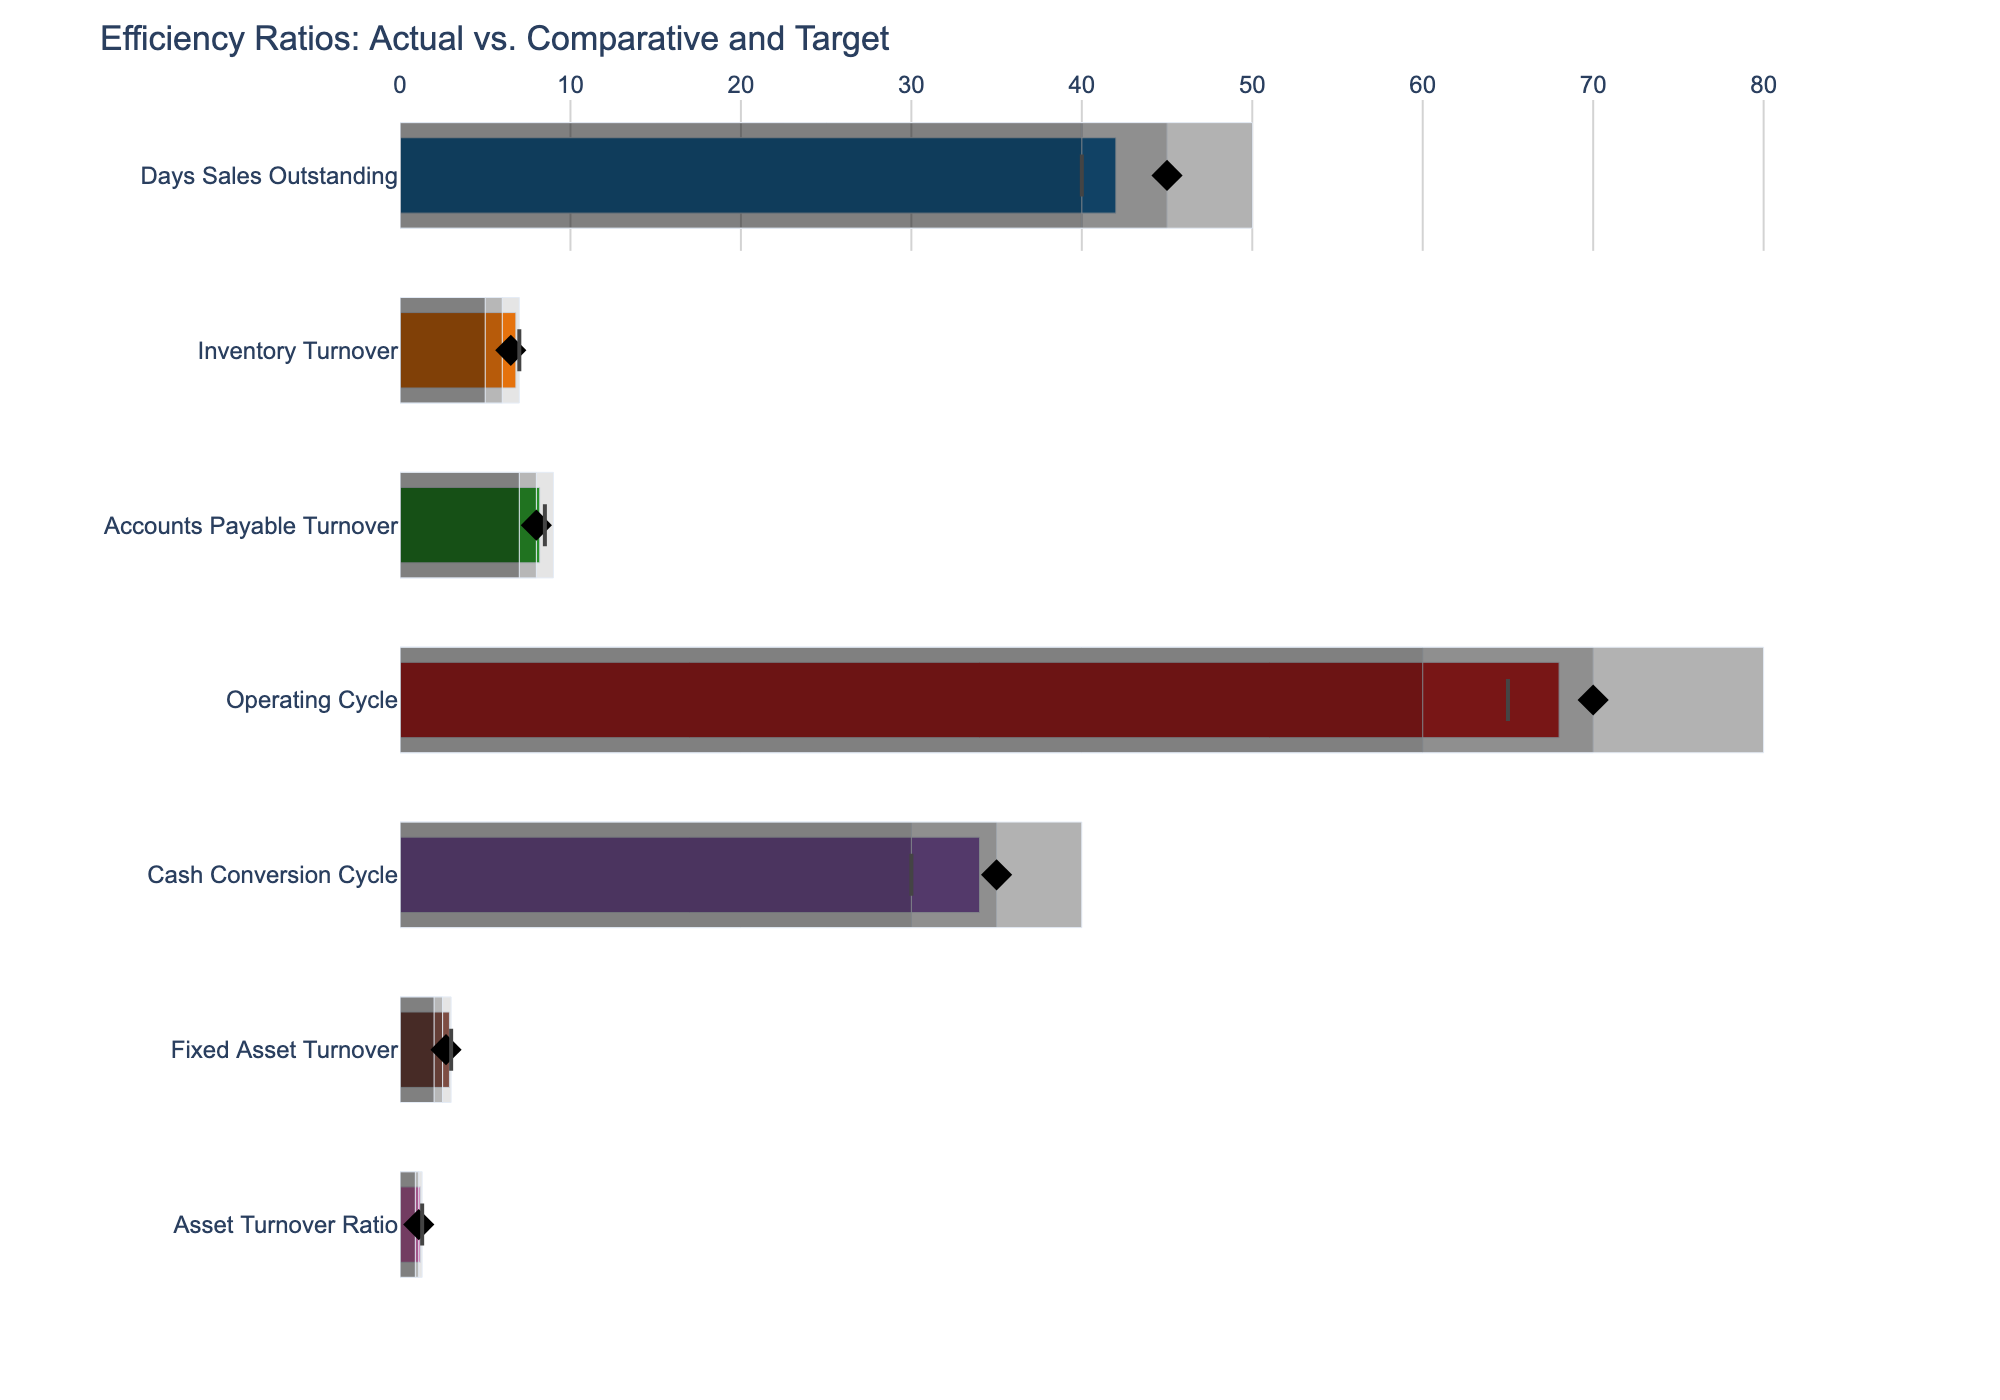What's the title of the figure? The title is typically located at the top of the figure. It provides a summary description of what the chart represents.
Answer: Efficiency Ratios: Actual vs. Comparative and Target Which category has the highest Actual value? To find this, we look for the longest bar among the actual values for all categories. The highest Actual value is 68, which corresponds to the Operating Cycle.
Answer: Operating Cycle How does the Actual Days Sales Outstanding compare to its Target? Observe the bar for the Actual value of Days Sales Outstanding and compare its length to the position of the red marker, which denotes the Target. Actual (42) is higher than the Target (40).
Answer: Higher Which categories have an Actual value below their Comparative value? Compare the Actual value bar to the diamond marker representing Comparative values for all categories. Categories with Actual less than Comparative are Inventory Turnover and Asset Turnover Ratio.
Answer: Inventory Turnover, Asset Turnover Ratio Is the Actual value of Cash Conversion Cycle within its acceptable range? Verify if the bar for the Actual value of Cash Conversion Cycle falls within the ranges marked by different shades in the chart. The Actual value of 34 falls within the range of 30-35.
Answer: Yes What's the difference between the Actual and Target values for Fixed Asset Turnover? Subtract the Target value from the Actual value for Fixed Asset Turnover. The Actual is 2.9 and the Target is 3, resulting in a difference of 2.9 - 3 = -0.1.
Answer: -0.1 Which category shows the smallest deviation from its Target value? Calculate the absolute difference between Actual and Target values for each category and identify the smallest deviation. The smallest deviation is for Days Sales Outstanding, which is 2 (42 - 40).
Answer: Days Sales Outstanding What is the range for Inventory Turnover, and how does the Actual value fit within this range? Check the lightest to darkest shades marking the range for Inventory Turnover. The range is from 5 to 7, and the Actual value is 6.8, which lies within this range.
Answer: Within range (5 to 7) For how many categories is the Actual value higher than the Range1 value? Compare the Actual value bar to the first (darkest) range bar for each category. The Actual values are higher than Range1 for all categories.
Answer: All categories What's the average Actual value across all categories? Sum the Actual values for all categories and divide by the number of categories. Sum: 42 + 6.8 + 8.2 + 68 + 34 + 2.9 + 1.2 = 163.1. Number of categories: 7. Average = 163.1 / 7 ≈ 23.3
Answer: 23.3 